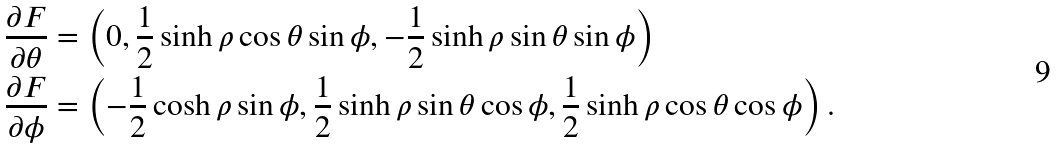Convert formula to latex. <formula><loc_0><loc_0><loc_500><loc_500>\frac { \partial F } { \partial \theta } & = \left ( 0 , \frac { 1 } { 2 } \sinh \rho \cos \theta \sin \phi , - \frac { 1 } { 2 } \sinh \rho \sin \theta \sin \phi \right ) \\ \frac { \partial F } { \partial \phi } & = \left ( - \frac { 1 } { 2 } \cosh \rho \sin \phi , \frac { 1 } { 2 } \sinh \rho \sin \theta \cos \phi , \frac { 1 } { 2 } \sinh \rho \cos \theta \cos \phi \right ) .</formula> 